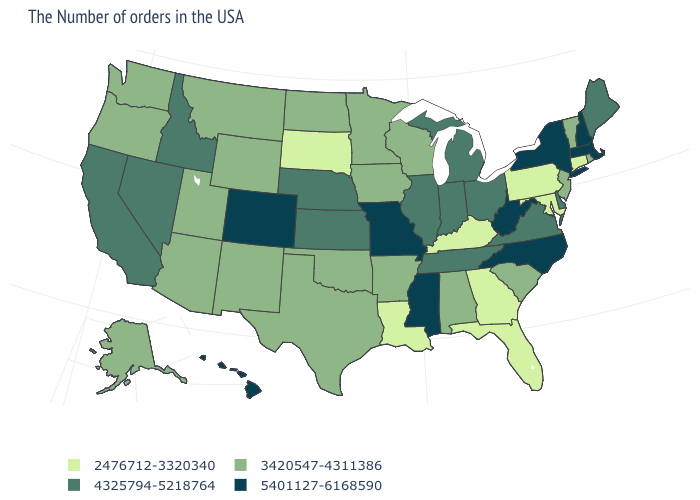Name the states that have a value in the range 5401127-6168590?
Short answer required. Massachusetts, New Hampshire, New York, North Carolina, West Virginia, Mississippi, Missouri, Colorado, Hawaii. How many symbols are there in the legend?
Be succinct. 4. What is the highest value in the MidWest ?
Be succinct. 5401127-6168590. What is the value of Kentucky?
Short answer required. 2476712-3320340. Which states hav the highest value in the MidWest?
Write a very short answer. Missouri. Which states have the lowest value in the South?
Be succinct. Maryland, Florida, Georgia, Kentucky, Louisiana. Which states have the highest value in the USA?
Answer briefly. Massachusetts, New Hampshire, New York, North Carolina, West Virginia, Mississippi, Missouri, Colorado, Hawaii. Among the states that border Nebraska , does Kansas have the highest value?
Quick response, please. No. Does Pennsylvania have a higher value than Wisconsin?
Be succinct. No. Is the legend a continuous bar?
Short answer required. No. Among the states that border Delaware , does Pennsylvania have the highest value?
Give a very brief answer. No. Name the states that have a value in the range 2476712-3320340?
Short answer required. Connecticut, Maryland, Pennsylvania, Florida, Georgia, Kentucky, Louisiana, South Dakota. What is the lowest value in states that border Colorado?
Quick response, please. 3420547-4311386. Among the states that border Idaho , which have the highest value?
Be succinct. Nevada. What is the value of Florida?
Keep it brief. 2476712-3320340. 